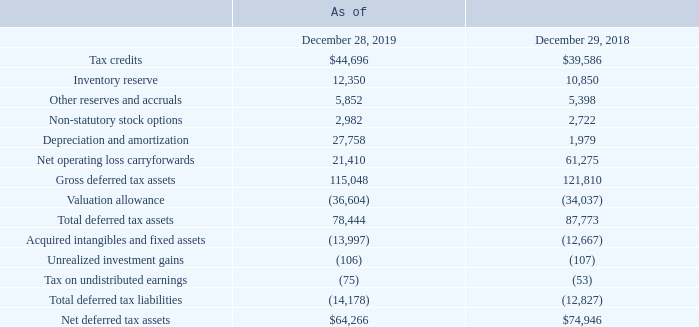Deferred Tax Assets and Liabilities
Deferred tax assets and liabilities are recognized for the future tax consequences of differences between the carrying amounts of assets and liabilities and their respective tax basis using enacted tax rates in effect for the year in which the differences are expected to be reversed.
Significant deferred tax assets and liabilities consisted of the following (in thousands):
We are required to evaluate the realizability of our deferred tax assets in both our U.S. and non-U.S. jurisdictions on an ongoing basis to determine whether there is a need for a valuation allowance with respect to such deferred tax assets. From the fourth quarter of fiscal 2009 to the third quarter of fiscal 2018, we maintained a 100% valuation allowance against most of our U.S. deferred tax assets because there was insufficient positive evidence to overcome the existing negative evidence such that it was not more likely than not that the U.S. deferred tax assets were realizable.
While we reported U.S. pre-tax income in fiscal 2015 and fiscal 2017, because we reported U.S. pre-tax losses during the previous seven fiscal years, we continued to maintain the 100% valuation allowance through the third quarter of fiscal 2018.
As of December 29, 2018, we had reported positive operating performance in the U.S. for two consecutive fiscal years and had also reported a cumulative threeyear U.S. pre-tax profit. In addition, during the fourth quarter of fiscal 2018, we completed our financial plan for fiscal 2019 and expected continued positive operating performance in the U.S. We also considered forecasts of future taxable income and evaluated the utilization of net operating losses and tax credit carryforwards prior to their expiration.
After considering these factors, we determined that the positive evidence overcame any negative evidence and concluded that it was more likely than not that the U.S. deferred tax assets were realizable. As a result, we released the valuation allowance against a significant portion of the U.S. federal deferred tax assets and a portion of the U.S. state deferred tax assets during the fourth quarter of fiscal 2018.
The valuation allowance decreased by $75.8 million in fiscal 2018, primarily due to the release of the valuation allowance on U.S. deferred tax assets. As of December 28, 2019, we maintained a valuation allowance of $36.6 million, primarily related to California deferred tax assets and foreign tax credit carryovers, due to uncertainty about the future realization of these assets.
What was the valuation allowance maintained from fourth quarter of fiscal 2009 to the third quarter of fiscal 2018? 100%. What was the amount of valuation allowance decrease in fiscal 2018? $75.8 million. What were the tax credits in 2019 and 2018 respectively?
Answer scale should be: thousand. 44,696, 39,586. What is the change in the Tax credits from 2018 to 2019?
Answer scale should be: thousand. 44,696 - 39,586
Answer: 5110. What is the average Inventory reserve for 2018 and 2019?
Answer scale should be: thousand. (12,350 + 10,850) / 2
Answer: 11600. In which years is the Other reserves and accruals greater than 5,000 thousand? Locate and analyze the other reserves and accruals in row 5
answer: 2019, 2018. 